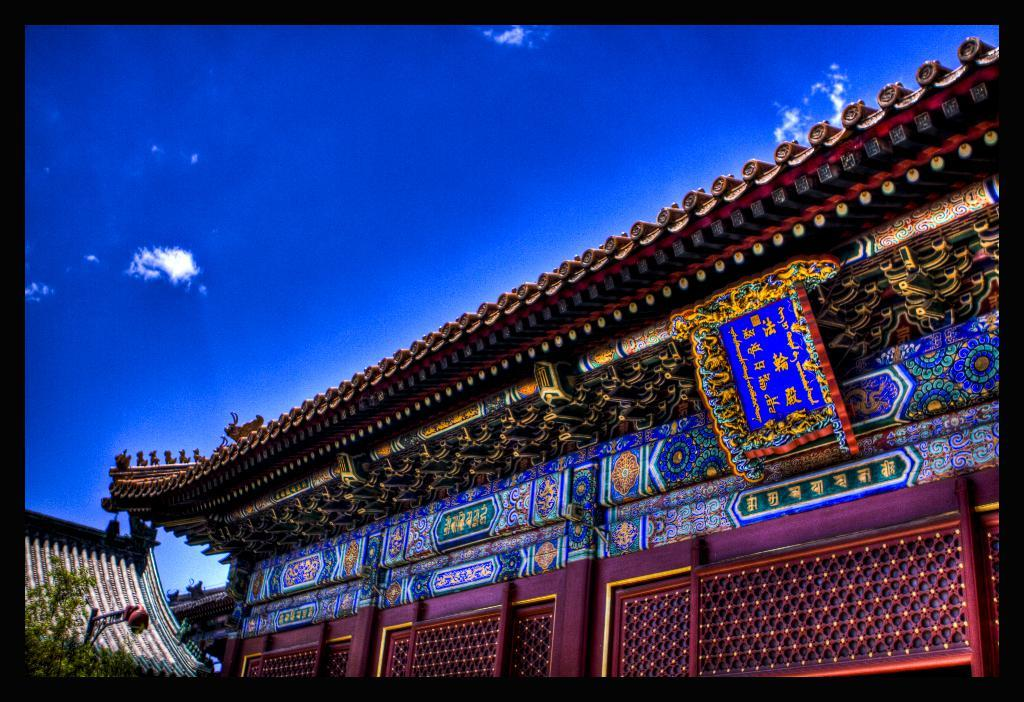What type of structures can be seen in the image? There are buildings in the image. What other natural elements are present in the image? There are trees in the image. What is visible in the background of the image? The sky is visible in the image. What type of metal is used to create the needles in the image? There are no needles present in the image, so it is not possible to determine the type of metal used. 